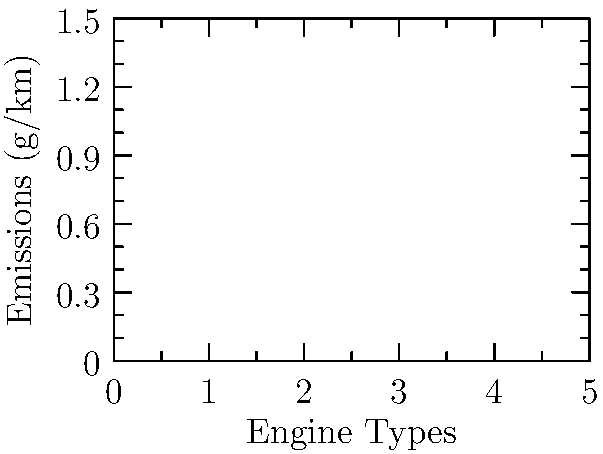As a journalist covering environmental issues in the automotive industry, you're preparing a report on the emissions performance of various engine types. Based on the emissions chart provided, which engine type demonstrates the lowest overall environmental impact in terms of CO, NOx, and PM emissions combined? How might this information influence public policy debates on sustainable transportation? To determine the engine type with the lowest overall environmental impact, we need to analyze the emissions data for each pollutant across all engine types:

1. CO (Carbon Monoxide) emissions:
   Gasoline: 0.5 g/km
   Diesel: 0.3 g/km
   Electric: 0.1 g/km
   Hybrid: 0.2 g/km

2. NOx (Nitrogen Oxides) emissions:
   Gasoline: 1.2 g/km
   Diesel: 0.9 g/km
   Electric: 0.4 g/km
   Hybrid: 0.7 g/km

3. PM (Particulate Matter) emissions:
   Gasoline: 0.8 g/km
   Diesel: 0.6 g/km
   Electric: 0.2 g/km
   Hybrid: 0.5 g/km

Comparing the values for each pollutant:

- Electric engines have the lowest emissions in all three categories.
- Hybrid engines have the second-lowest emissions in most categories.
- Diesel and gasoline engines generally have higher emissions across all pollutants.

The electric engine type clearly demonstrates the lowest overall environmental impact when considering CO, NOx, and PM emissions combined.

This information could influence public policy debates on sustainable transportation in several ways:

1. Support for electric vehicle infrastructure: Policymakers may push for increased investment in charging stations and grid improvements to support wider adoption of electric vehicles.

2. Incentives for electric and hybrid vehicles: Governments might introduce or expand tax credits, rebates, or other incentives for purchasing electric and hybrid vehicles.

3. Stricter emissions standards: The data could be used to justify more stringent emissions regulations for conventional gasoline and diesel engines.

4. Urban planning and air quality management: Cities might use this information to inform decisions about low-emission zones or congestion charging schemes.

5. Research and development funding: There could be increased support for further improving electric and hybrid technologies to enhance their environmental benefits.

6. Public awareness campaigns: Governments and environmental organizations might use this data to educate the public about the environmental impacts of different engine types.

As a journalist, presenting this information could contribute to a more informed public discourse on the environmental aspects of different engine technologies and their role in addressing climate change and air quality concerns.
Answer: Electric engines have the lowest environmental impact. 